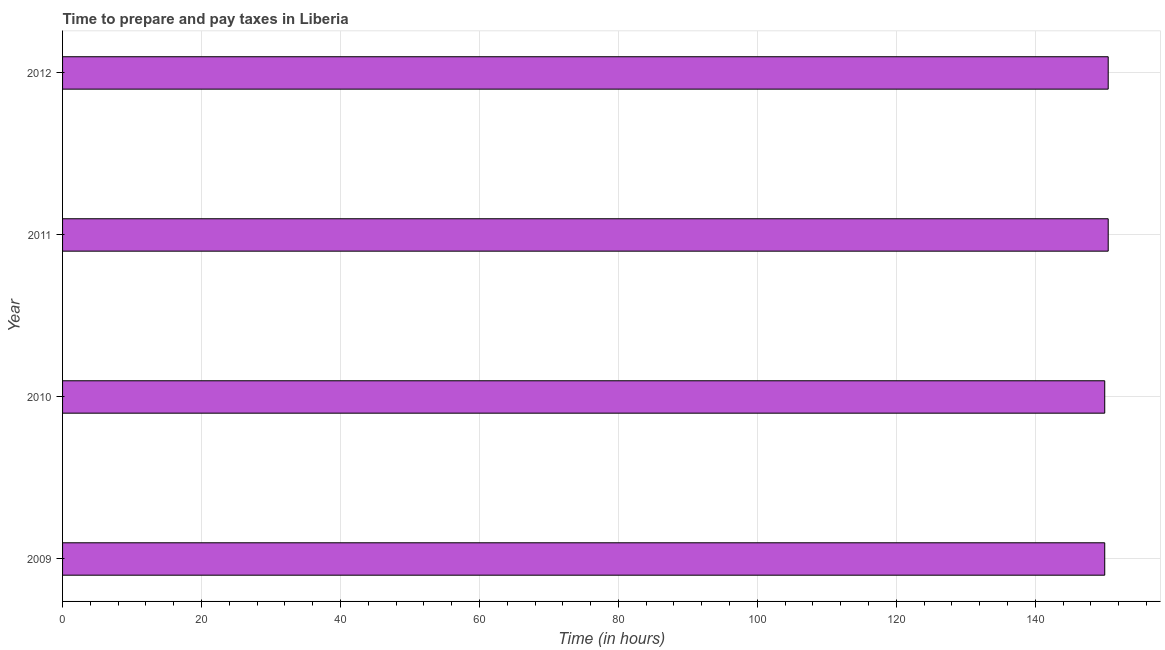Does the graph contain grids?
Keep it short and to the point. Yes. What is the title of the graph?
Offer a terse response. Time to prepare and pay taxes in Liberia. What is the label or title of the X-axis?
Ensure brevity in your answer.  Time (in hours). What is the label or title of the Y-axis?
Keep it short and to the point. Year. What is the time to prepare and pay taxes in 2010?
Ensure brevity in your answer.  150. Across all years, what is the maximum time to prepare and pay taxes?
Your answer should be compact. 150.5. Across all years, what is the minimum time to prepare and pay taxes?
Make the answer very short. 150. In which year was the time to prepare and pay taxes minimum?
Ensure brevity in your answer.  2009. What is the sum of the time to prepare and pay taxes?
Provide a succinct answer. 601. What is the difference between the time to prepare and pay taxes in 2009 and 2012?
Your answer should be very brief. -0.5. What is the average time to prepare and pay taxes per year?
Your answer should be very brief. 150.25. What is the median time to prepare and pay taxes?
Give a very brief answer. 150.25. In how many years, is the time to prepare and pay taxes greater than 108 hours?
Offer a terse response. 4. Is the difference between the time to prepare and pay taxes in 2011 and 2012 greater than the difference between any two years?
Provide a short and direct response. No. What is the difference between the highest and the lowest time to prepare and pay taxes?
Provide a short and direct response. 0.5. In how many years, is the time to prepare and pay taxes greater than the average time to prepare and pay taxes taken over all years?
Provide a succinct answer. 2. Are all the bars in the graph horizontal?
Your answer should be very brief. Yes. What is the Time (in hours) in 2009?
Offer a very short reply. 150. What is the Time (in hours) of 2010?
Ensure brevity in your answer.  150. What is the Time (in hours) of 2011?
Offer a very short reply. 150.5. What is the Time (in hours) of 2012?
Ensure brevity in your answer.  150.5. What is the difference between the Time (in hours) in 2009 and 2010?
Offer a very short reply. 0. What is the difference between the Time (in hours) in 2009 and 2012?
Give a very brief answer. -0.5. What is the difference between the Time (in hours) in 2010 and 2011?
Make the answer very short. -0.5. What is the ratio of the Time (in hours) in 2009 to that in 2010?
Your answer should be compact. 1. What is the ratio of the Time (in hours) in 2009 to that in 2011?
Offer a terse response. 1. What is the ratio of the Time (in hours) in 2010 to that in 2011?
Offer a very short reply. 1. What is the ratio of the Time (in hours) in 2011 to that in 2012?
Your answer should be very brief. 1. 